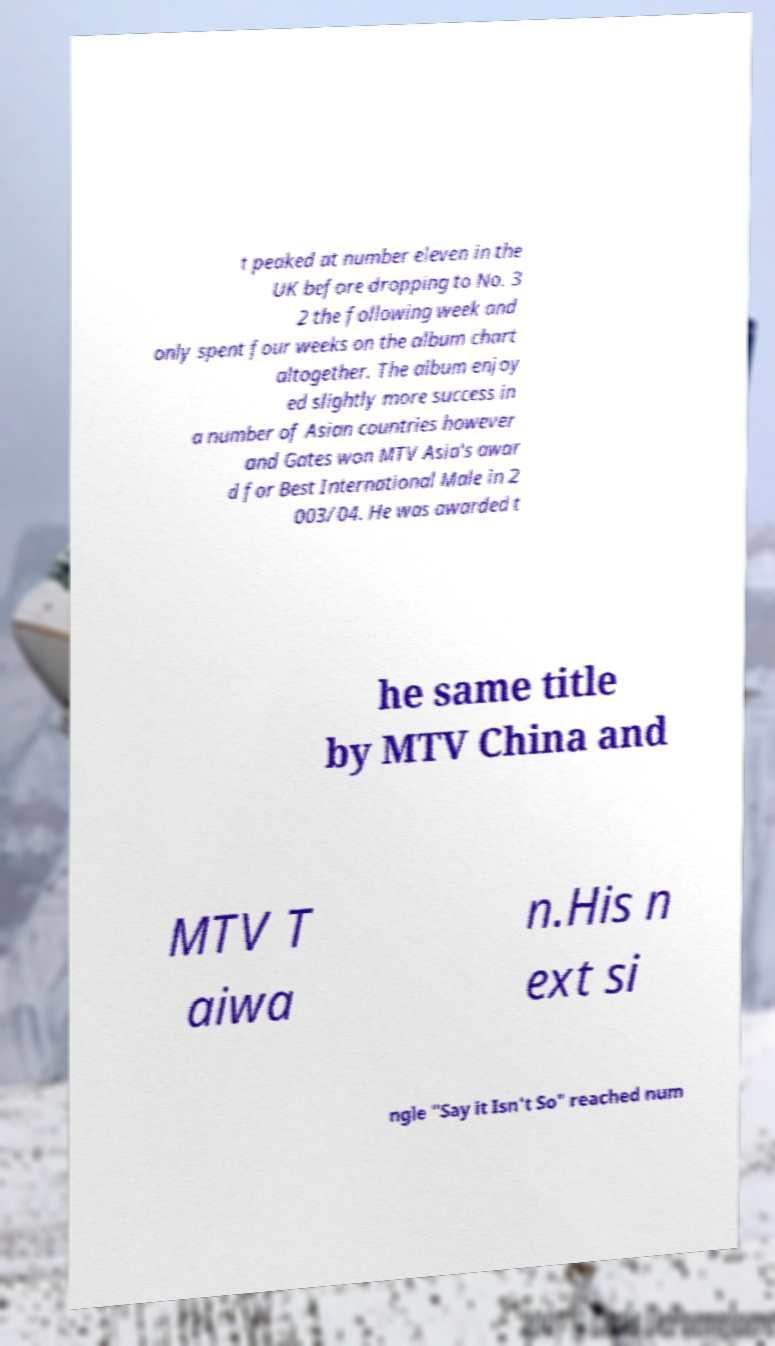Please identify and transcribe the text found in this image. t peaked at number eleven in the UK before dropping to No. 3 2 the following week and only spent four weeks on the album chart altogether. The album enjoy ed slightly more success in a number of Asian countries however and Gates won MTV Asia's awar d for Best International Male in 2 003/04. He was awarded t he same title by MTV China and MTV T aiwa n.His n ext si ngle "Say it Isn't So" reached num 